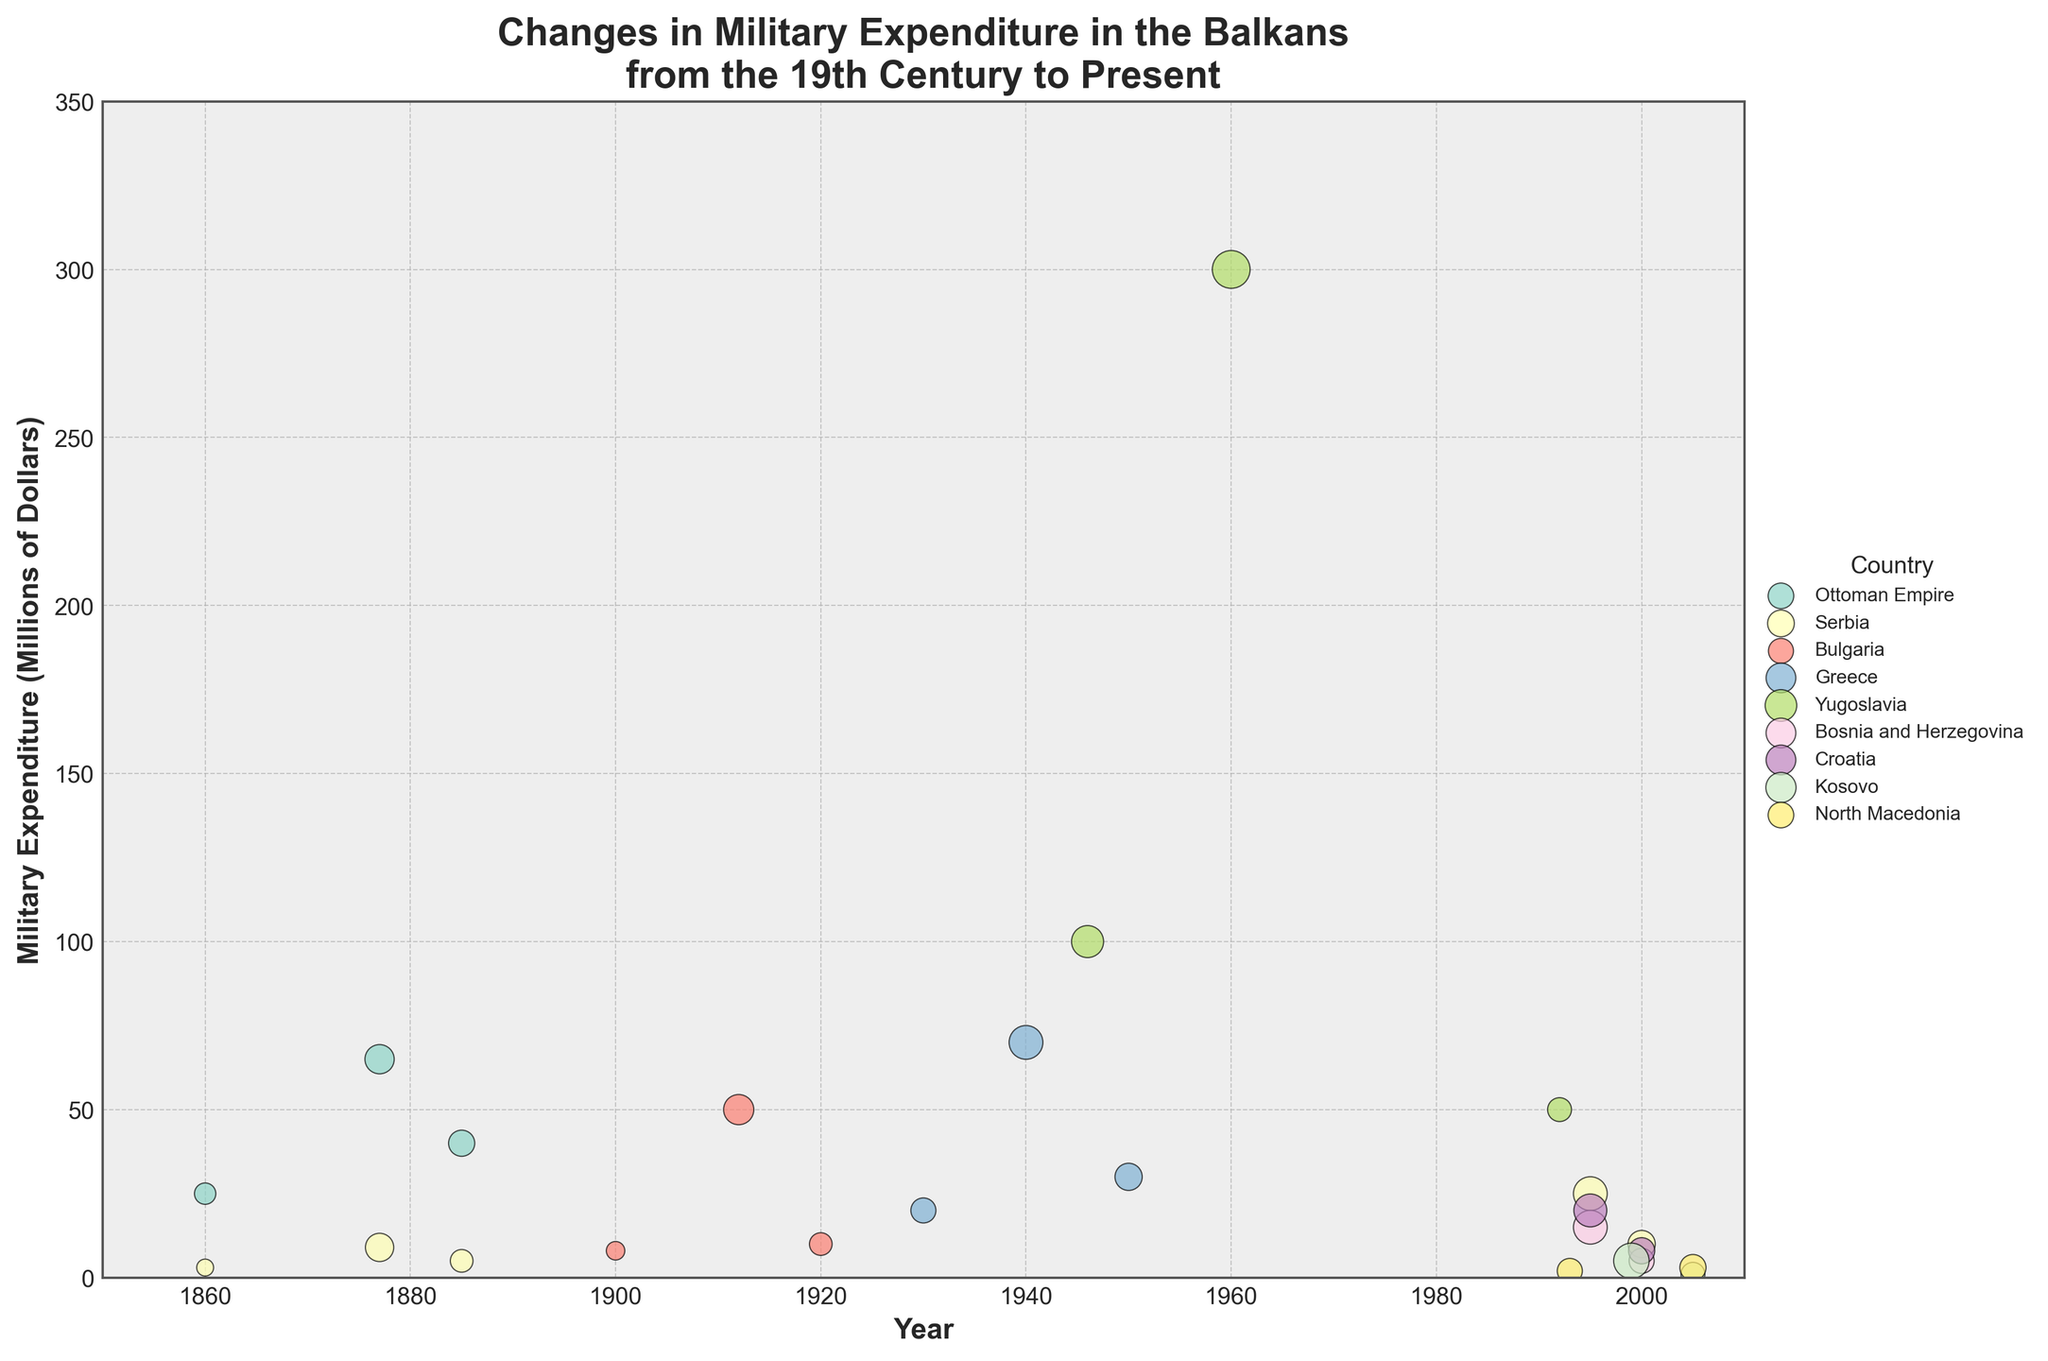What is the title of the figure? The title of the figure is typically placed at the top and is designed to give a summary of the plot content. Here, it states "Changes in Military Expenditure in the Balkans from the 19th Century to Present".
Answer: Changes in Military Expenditure in the Balkans from the 19th Century to Present Which period and country have the largest military expenditure according to the figure? To determine this, look for the largest bubble on the chart. The bubble representing Yugoslavia during the Cold War period stands out as the largest one, indicating the highest military expenditure of 300 million dollars.
Answer: Yugoslavia during the Cold War Which countries are represented in the figure? The countries are differentiated by color and are listed in the legend. Examine the legend to find the countries included: Ottoman Empire, Serbia, Bulgaria, Greece, Yugoslavia, Bosnia and Herzegovina, Croatia, Kosovo, and North Macedonia.
Answer: Ottoman Empire, Serbia, Bulgaria, Greece, Yugoslavia, Bosnia and Herzegovina, Croatia, Kosovo, North Macedonia What is the military expenditure of Greece during WWII according to the figure? Locate Greece among the plotted points and identify the year range that includes WWII, which is the 1940 data point. The size of the bubble representing 70 million dollars provides the necessary information.
Answer: 70 million dollars Which country had the lowest military expenditure post-conflict, and what was the expenditure? Compare the sizes of the post-conflict bubbles, looking for the smallest one. Kosovo’s post-Kosovo War in 2005 had the smallest bubble, representing 1 million dollars in military expenditure.
Answer: Kosovo, 1 million dollars Between Serbia in the Russo-Turkish War and Serbia in the Post-Russo-Turkish War, how did the military expenditure change? Identify the bubbles for Serbia during the Russo-Turkish War (1877) and the Post-Russo-Turkish War (1885). The figure shows an expenditure decrease from 9 million dollars in 1877 to 5 million dollars in 1885.
Answer: Decreased from 9 million dollars to 5 million dollars Which country and period had the highest impact factor according to the figure? Examine bubble sizes as they correspond to impact factors. The largest factor is associated with Yugoslavia during the Cold War, which has an impact factor of 2.5.
Answer: Yugoslavia during Cold War What is the overall trend in military expenditure in the Balkan region from the 19th century to the present based on the figure? Observe the placement and size of bubbles through different time periods. Initially low during the 19th century, expenditures peak during major conflicts such as the Cold War and World War II, and then fluctuate with each subsequent conflict.
Answer: Increasing during conflicts, fluctuating afterwards Compare the military expenditure of Bosnia and Herzegovina and Croatia during the Bosnian War. Which country spent more, and by how much? Identify the bubbles for Bosnia and Herzegovina and Croatia during the 1995 Bosnian War. Bosnia and Herzegovina spent 15 million dollars, while Croatia spent 20 million dollars, so Croatia spent 5 million dollars more.
Answer: Croatia spent 5 million dollars more How did military expenditures change for North Macedonia from Post-Independence 1993 to 2005? Look for the bubbles corresponding to North Macedonia in 1993 and 2005. Military expenditure increased from 2 million dollars in 1993 to 3 million dollars in 2005. Calculate the difference.
Answer: Increased by 1 million dollar 